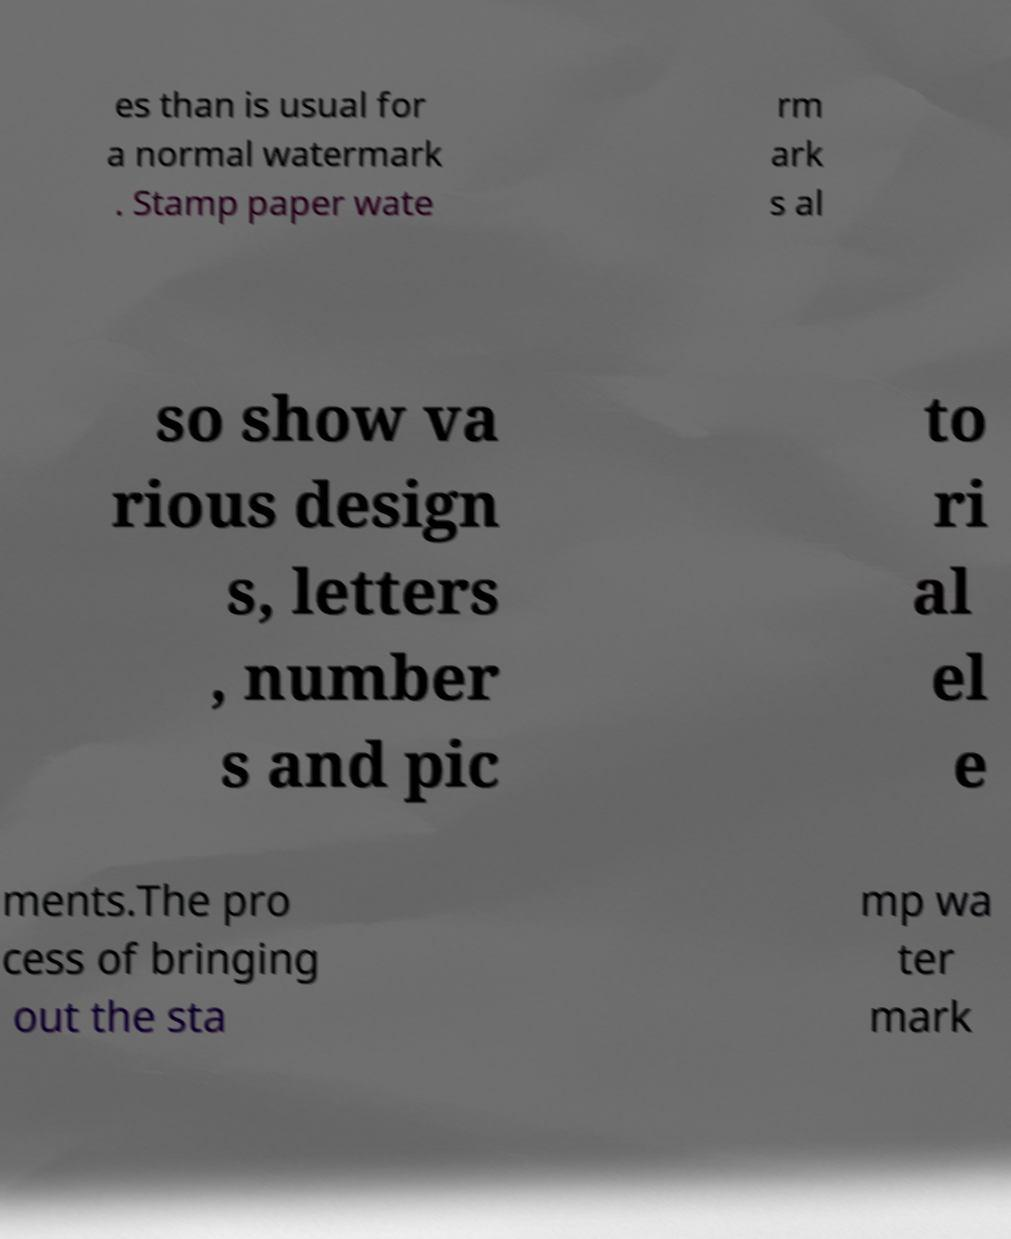Can you accurately transcribe the text from the provided image for me? es than is usual for a normal watermark . Stamp paper wate rm ark s al so show va rious design s, letters , number s and pic to ri al el e ments.The pro cess of bringing out the sta mp wa ter mark 